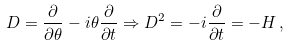Convert formula to latex. <formula><loc_0><loc_0><loc_500><loc_500>D = \frac { \partial } { \partial \theta } - i \theta \frac { \partial } { \partial t } \Rightarrow D ^ { 2 } = - i \frac { \partial } { \partial t } = - H \, ,</formula> 